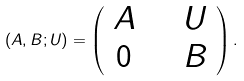Convert formula to latex. <formula><loc_0><loc_0><loc_500><loc_500>( A , B ; U ) = \left ( \begin{array} { c c } A \quad & U \\ 0 \quad & B \end{array} \right ) .</formula> 